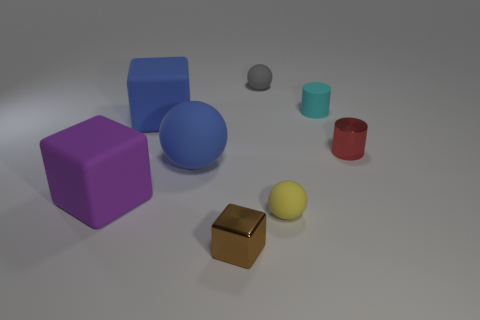Add 1 cyan cylinders. How many objects exist? 9 Subtract all big blocks. How many blocks are left? 1 Subtract all gray balls. How many balls are left? 2 Subtract all cylinders. How many objects are left? 6 Subtract 1 balls. How many balls are left? 2 Add 4 tiny blue balls. How many tiny blue balls exist? 4 Subtract 0 blue cylinders. How many objects are left? 8 Subtract all red cylinders. Subtract all green blocks. How many cylinders are left? 1 Subtract all gray cubes. How many red cylinders are left? 1 Subtract all purple things. Subtract all small gray matte spheres. How many objects are left? 6 